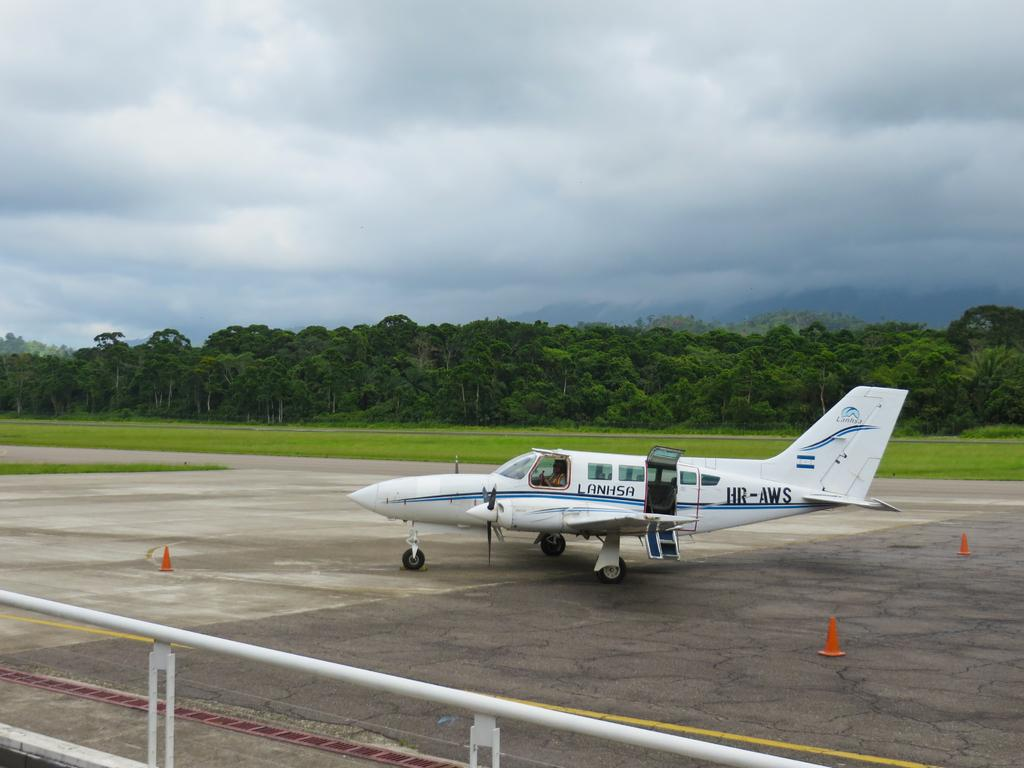<image>
Create a compact narrative representing the image presented. A small plane has Lanhsa on the side between two doors. 